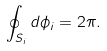<formula> <loc_0><loc_0><loc_500><loc_500>\oint _ { S _ { i } } { d \phi _ { i } } = 2 \pi .</formula> 